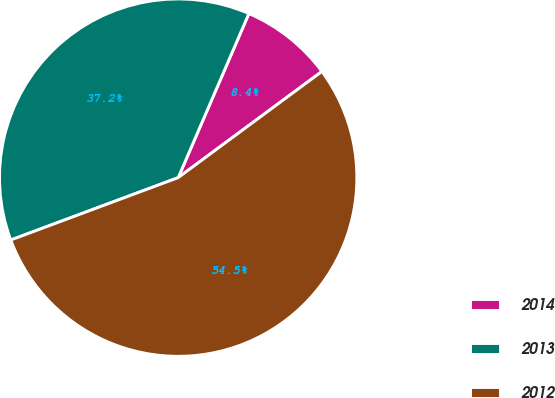<chart> <loc_0><loc_0><loc_500><loc_500><pie_chart><fcel>2014<fcel>2013<fcel>2012<nl><fcel>8.4%<fcel>37.15%<fcel>54.45%<nl></chart> 